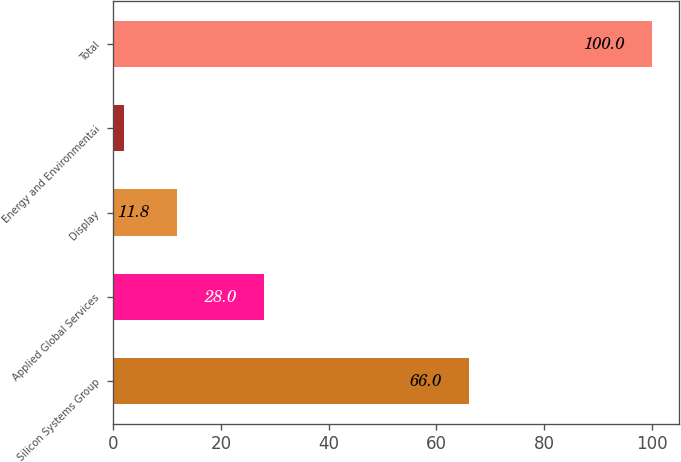<chart> <loc_0><loc_0><loc_500><loc_500><bar_chart><fcel>Silicon Systems Group<fcel>Applied Global Services<fcel>Display<fcel>Energy and Environmental<fcel>Total<nl><fcel>66<fcel>28<fcel>11.8<fcel>2<fcel>100<nl></chart> 